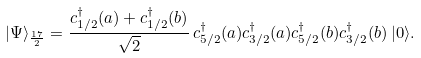Convert formula to latex. <formula><loc_0><loc_0><loc_500><loc_500>| \Psi \rangle _ { \frac { 1 7 } { 2 } } = \frac { c ^ { \dagger } _ { 1 / 2 } ( a ) + c ^ { \dagger } _ { 1 / 2 } ( b ) } { \sqrt { 2 } } \, c ^ { \dagger } _ { 5 / 2 } ( a ) c ^ { \dagger } _ { 3 / 2 } ( a ) c ^ { \dagger } _ { 5 / 2 } ( b ) c ^ { \dagger } _ { 3 / 2 } ( b ) \, | 0 \rangle .</formula> 